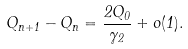Convert formula to latex. <formula><loc_0><loc_0><loc_500><loc_500>Q _ { n + 1 } - Q _ { n } = \frac { 2 Q _ { 0 } } { \gamma _ { 2 } } + o ( 1 ) .</formula> 